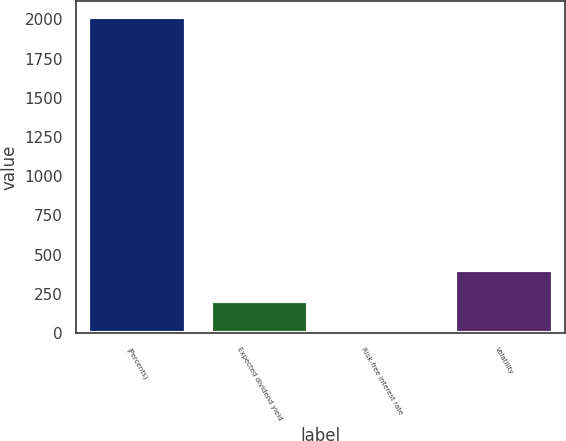Convert chart to OTSL. <chart><loc_0><loc_0><loc_500><loc_500><bar_chart><fcel>(Percents)<fcel>Expected dividend yield<fcel>Risk-free interest rate<fcel>Volatility<nl><fcel>2017<fcel>202.94<fcel>1.38<fcel>404.5<nl></chart> 